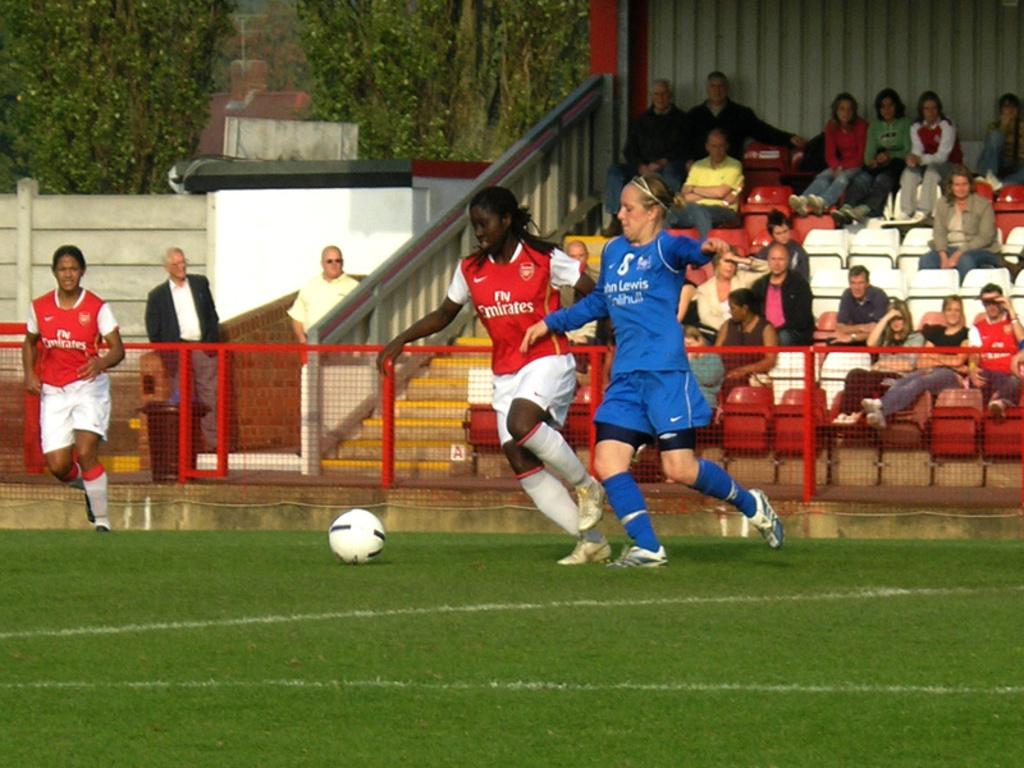<image>
Give a short and clear explanation of the subsequent image. A chelsea FC womans player tackles an Arsenal player in front of a small crowd... 